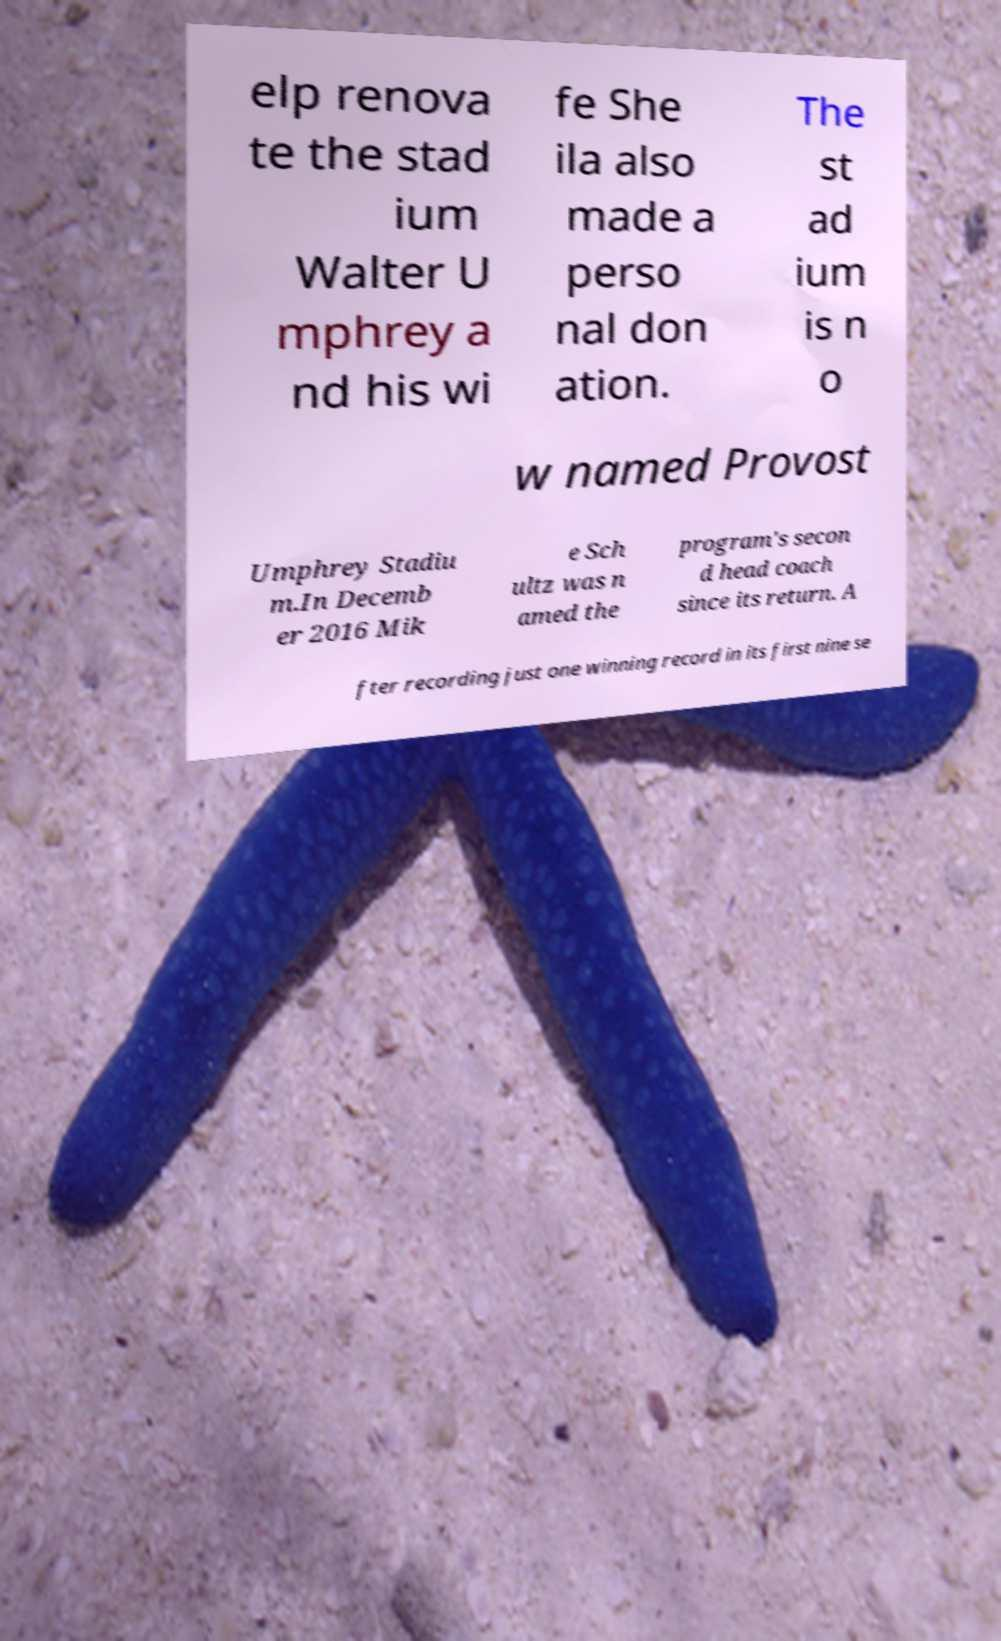For documentation purposes, I need the text within this image transcribed. Could you provide that? elp renova te the stad ium Walter U mphrey a nd his wi fe She ila also made a perso nal don ation. The st ad ium is n o w named Provost Umphrey Stadiu m.In Decemb er 2016 Mik e Sch ultz was n amed the program's secon d head coach since its return. A fter recording just one winning record in its first nine se 